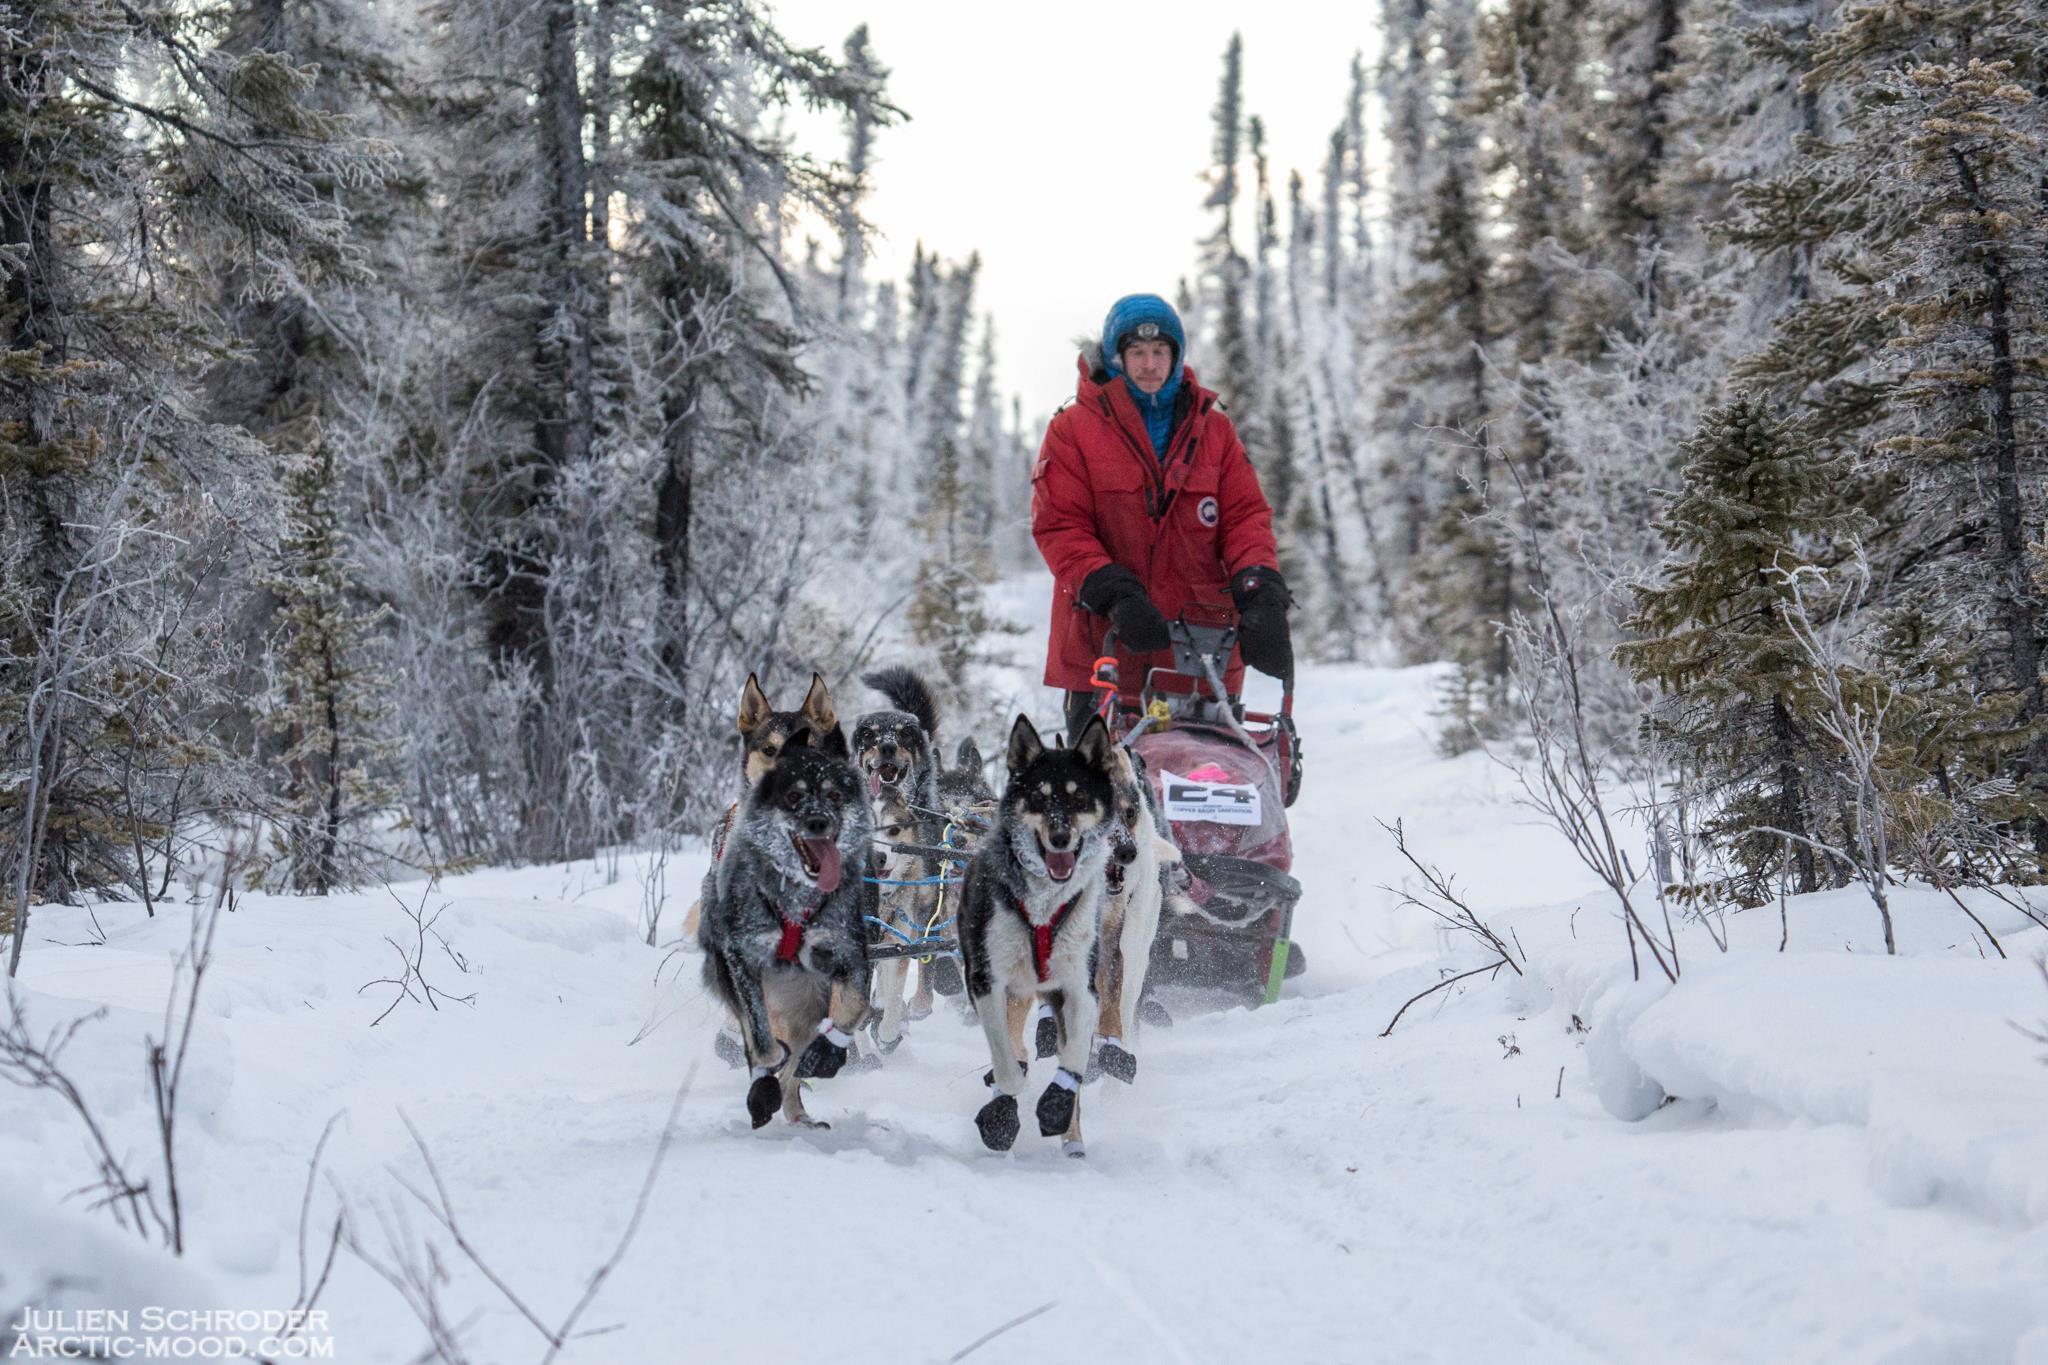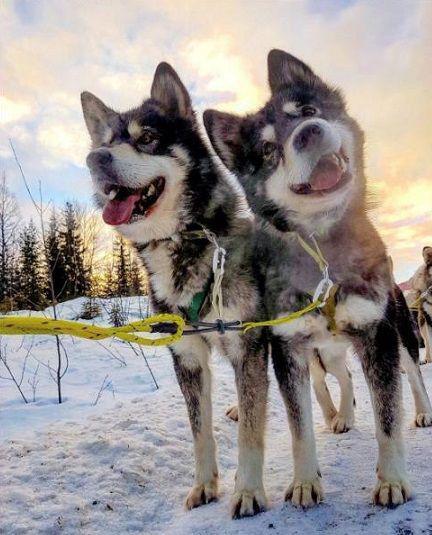The first image is the image on the left, the second image is the image on the right. For the images displayed, is the sentence "A person is being pulled by a team of dogs in one image." factually correct? Answer yes or no. Yes. The first image is the image on the left, the second image is the image on the right. For the images displayed, is the sentence "There is exactly one dog in the image on the right." factually correct? Answer yes or no. No. 